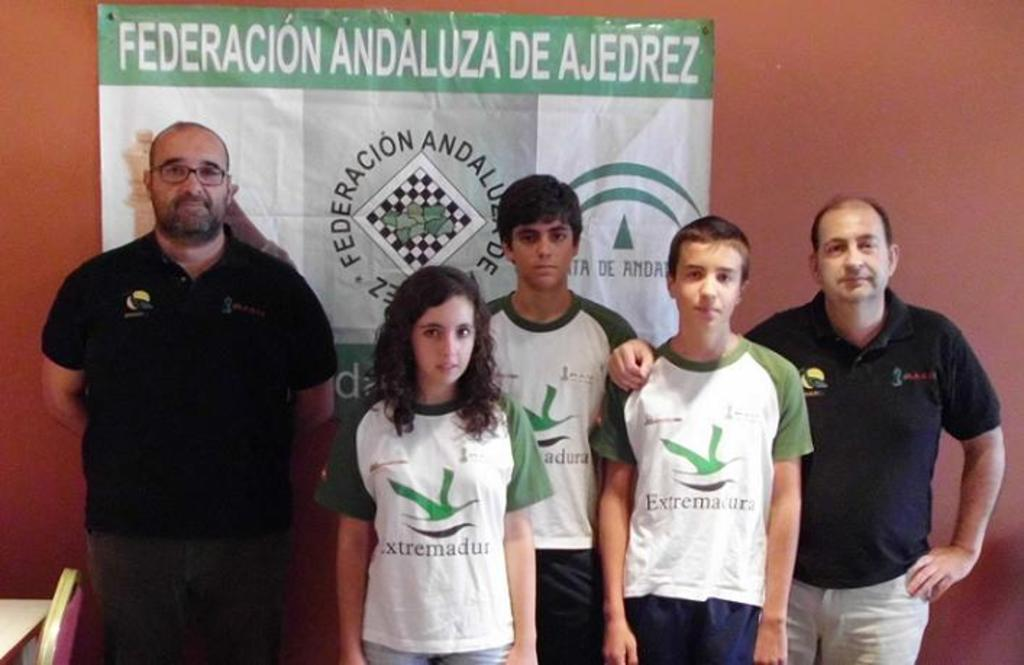<image>
Offer a succinct explanation of the picture presented. People standing in front of a banner which says  "Federacion Andaluza de Ajedrez". 